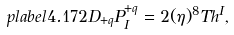Convert formula to latex. <formula><loc_0><loc_0><loc_500><loc_500>\ p l a b e l { 4 . 1 7 2 } D _ { + q } P ^ { + q } _ { I } = 2 ( \eta ) ^ { 8 } T h ^ { I } ,</formula> 